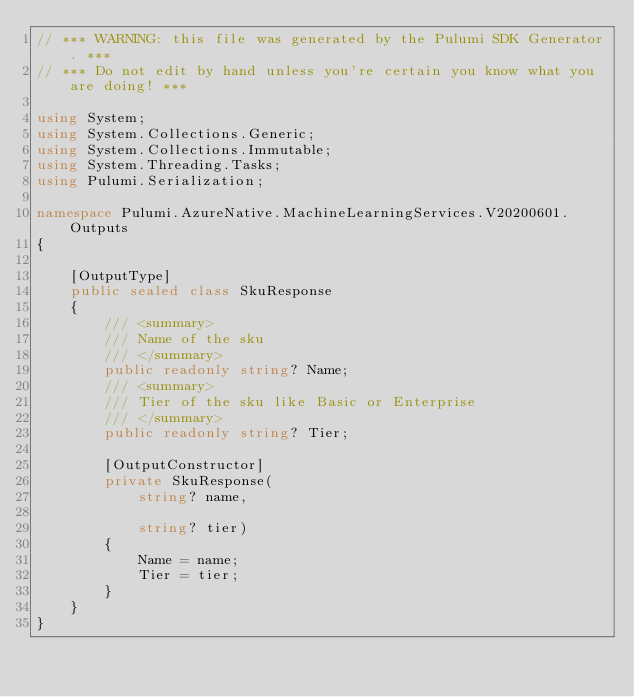Convert code to text. <code><loc_0><loc_0><loc_500><loc_500><_C#_>// *** WARNING: this file was generated by the Pulumi SDK Generator. ***
// *** Do not edit by hand unless you're certain you know what you are doing! ***

using System;
using System.Collections.Generic;
using System.Collections.Immutable;
using System.Threading.Tasks;
using Pulumi.Serialization;

namespace Pulumi.AzureNative.MachineLearningServices.V20200601.Outputs
{

    [OutputType]
    public sealed class SkuResponse
    {
        /// <summary>
        /// Name of the sku
        /// </summary>
        public readonly string? Name;
        /// <summary>
        /// Tier of the sku like Basic or Enterprise
        /// </summary>
        public readonly string? Tier;

        [OutputConstructor]
        private SkuResponse(
            string? name,

            string? tier)
        {
            Name = name;
            Tier = tier;
        }
    }
}
</code> 